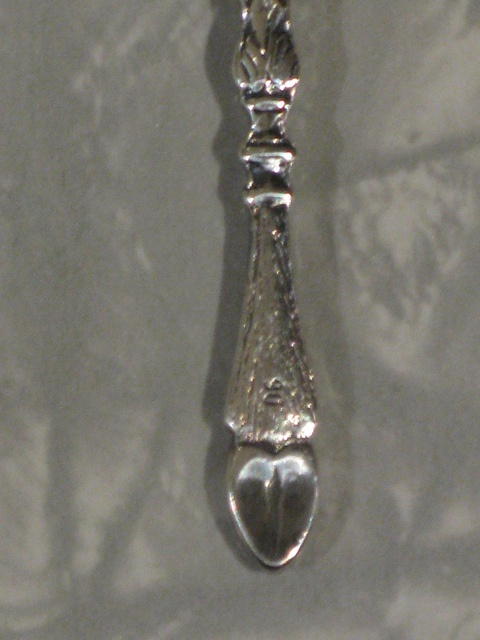Describe the objects in this image and their specific colors. I can see a spoon in gray, black, and darkgray tones in this image. 